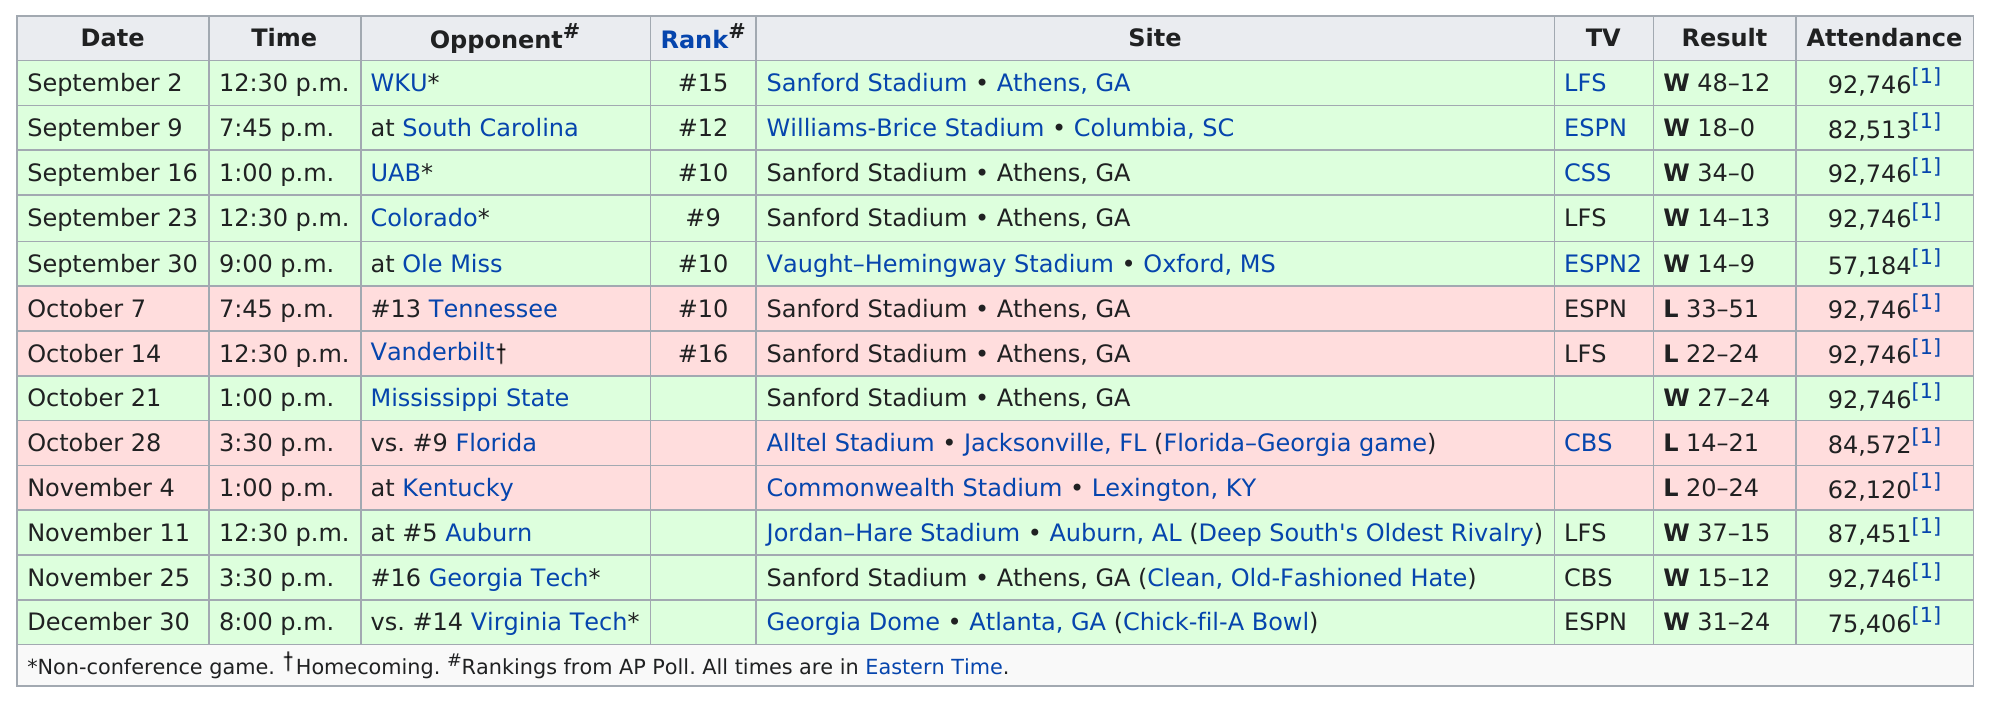Give some essential details in this illustration. Before 3:00 p.m., 7 games were played. On September 2, in a particular game, Georgia scored the largest amount of points. On October 7, the rank of the team was number 10. The Bulldogs won by a record-breaking number of points, 48, in their most recent game. On November 11 or November 25, which day had a greater attendance? The evidence suggests that November 25 may have had a higher turnout. 